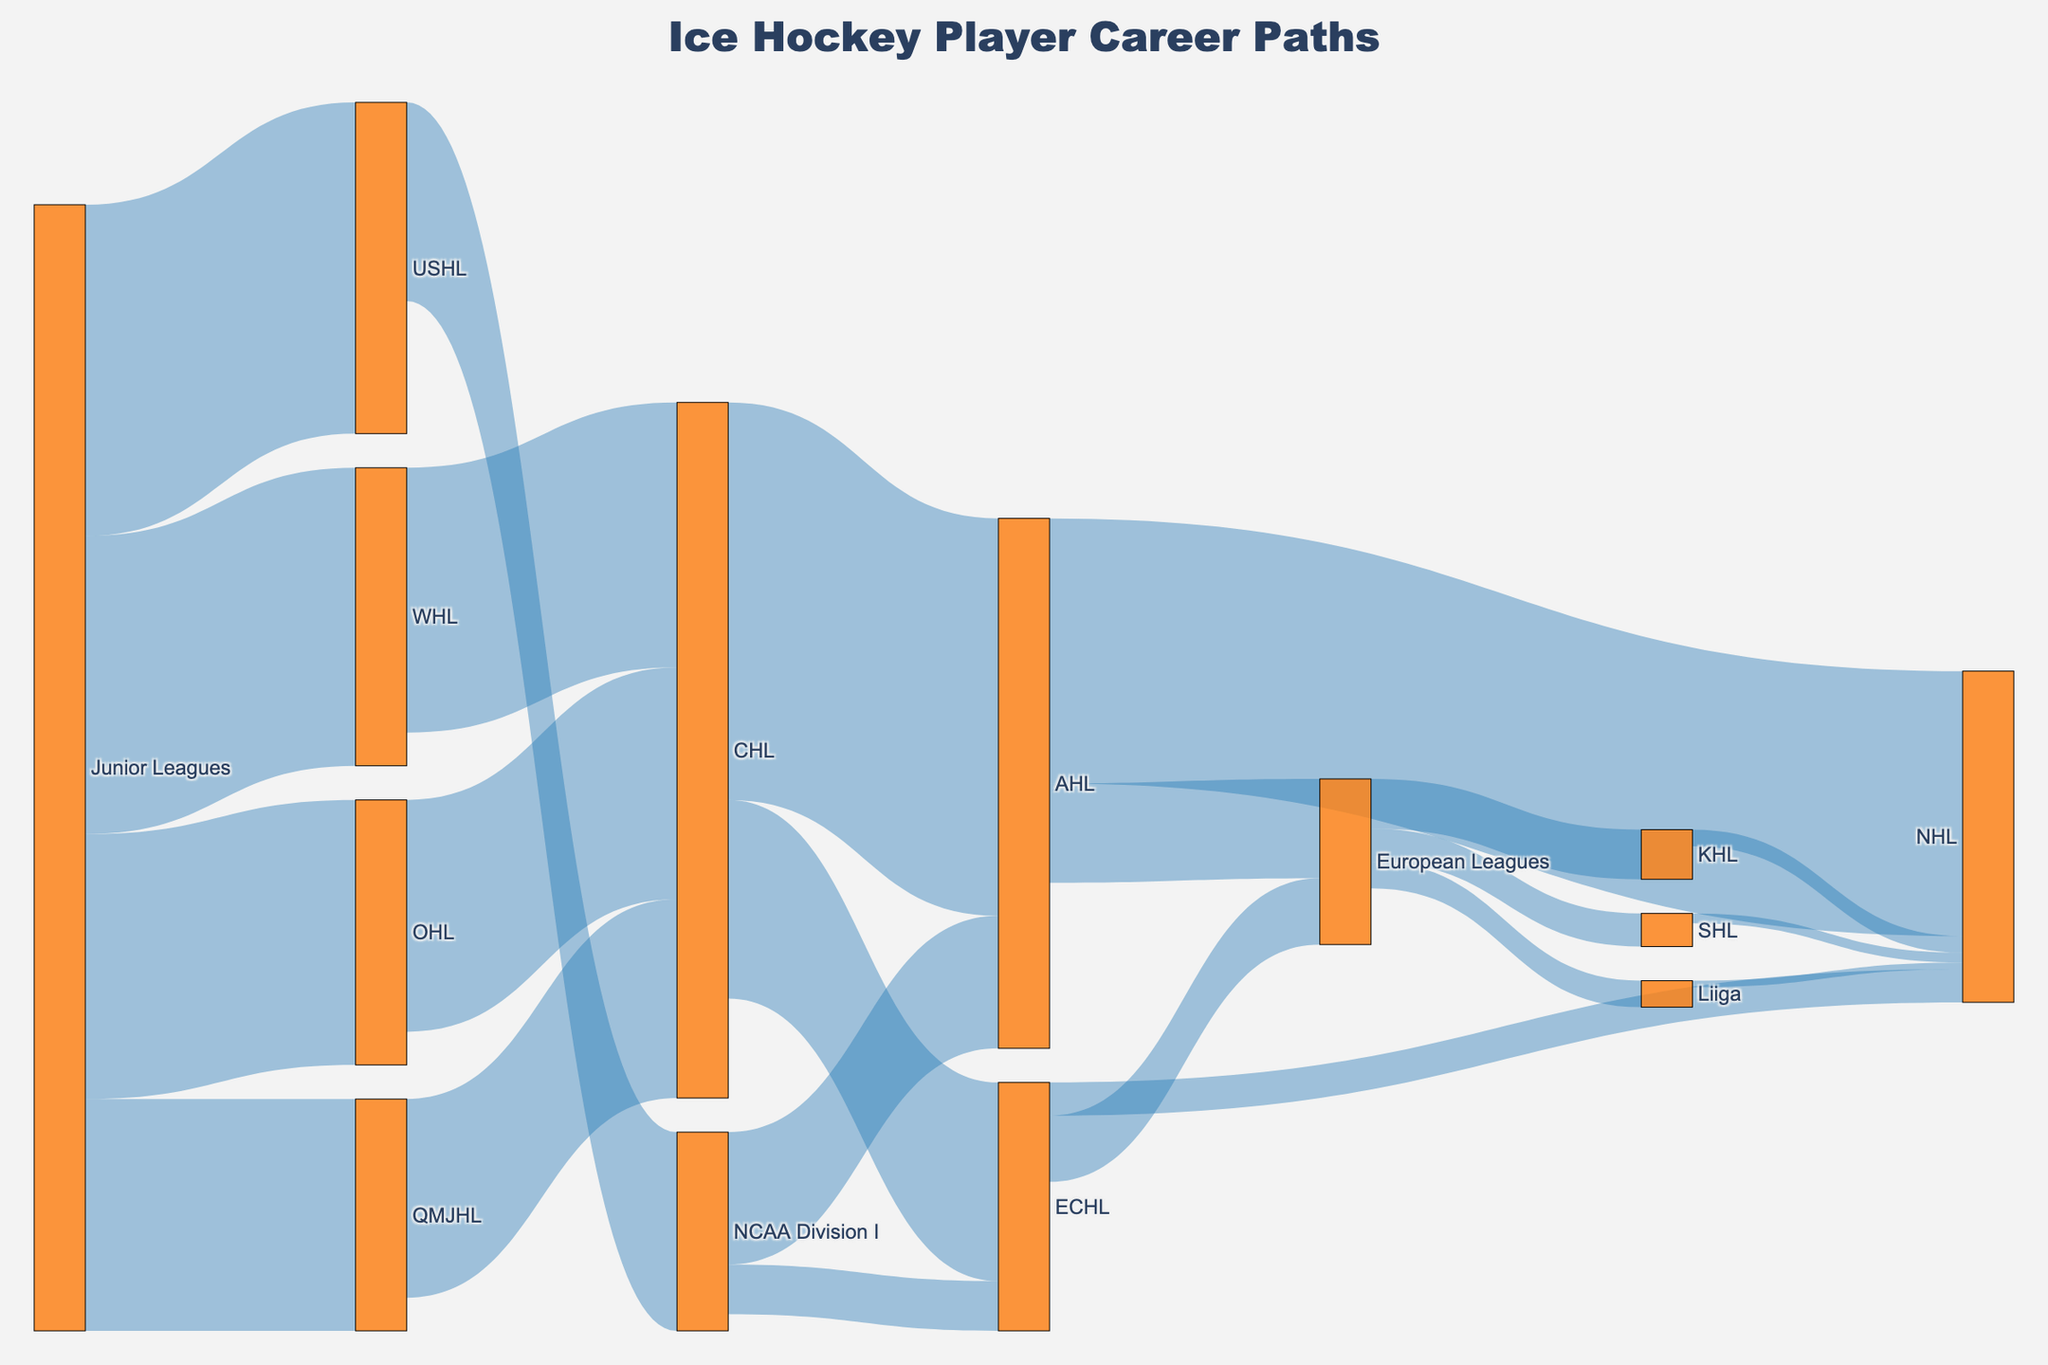What is the title of the diagram? The title is usually displayed at the top of the diagram. In this case, we see the title "Ice Hockey Player Career Paths" in bold, centered at the top.
Answer: Ice Hockey Player Career Paths How many leagues are represented in the diagram? By counting each unique label on the nodes, we can see that there are 15 different leagues or categories (Junior Leagues, USHL, OHL, WHL, QMJHL, NCAA Division I, CHL, AHL, ECHL, European Leagues, KHL, SHL, Liiga, and NHL).
Answer: 15 Which junior league leads the most players to the USHL? By looking at the connections from "Junior Leagues" to various targets, we see that "Junior Leagues" to "USHL" has a value of 100, which is the only incoming flow to USHL.
Answer: Junior Leagues Which league contributes the most players to the NCAA Division I? From the arrows linking to "NCAA Division I", we find that only the USHL has an incoming flow with a value of 60 feeding into NCAA Division I.
Answer: USHL What is the sum of players transitioning from the CHL to professional-level leagues (AHL and ECHL)? Sum the values flowing from CHL to AHL (120) and CHL to ECHL (60): 120 + 60 = 180
Answer: 180 Compare the number of players transitioning to the NHL from the AHL and ECHL. Which league contributes more? Look at the flows to the NHL: AHL to NHL has a value of 80, and ECHL to NHL has a value of 10. Therefore, AHL contributes more players.
Answer: AHL How many leagues serve as sources for the European Leagues? Identify and count the inflows to "European Leagues". There are two arrows with values originating from AHL (30) and ECHL (20).
Answer: 2 What is the value of players transitioning from European Leagues to SHL? Locate the connection from "European Leagues" to "SHL". The value of this connection is 10.
Answer: 10 What is the combined value of players transitioning from the KHL, SHL, and Liiga to the NHL? Sum the values from KHL to NHL (5), SHL to NHL (3), and Liiga to NHL (2): 5 + 3 + 2 = 10
Answer: 10 Which node representing a professional league receives the highest number of players from other leagues? Look for the node with the highest sum of incoming flows to professional leagues. NHL receives 80 (AHL) + 10 (ECHL) + 5 (KHL) + 3 (SHL) + 2 (Liiga) = 100
Answer: NHL 